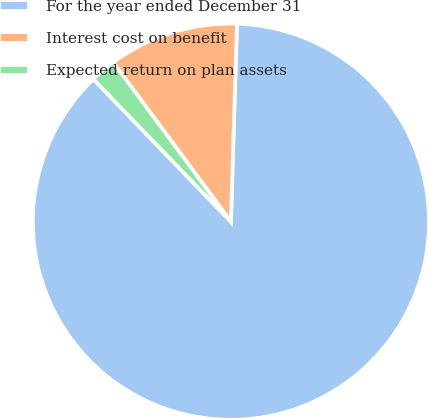Convert chart to OTSL. <chart><loc_0><loc_0><loc_500><loc_500><pie_chart><fcel>For the year ended December 31<fcel>Interest cost on benefit<fcel>Expected return on plan assets<nl><fcel>87.29%<fcel>10.61%<fcel>2.09%<nl></chart> 